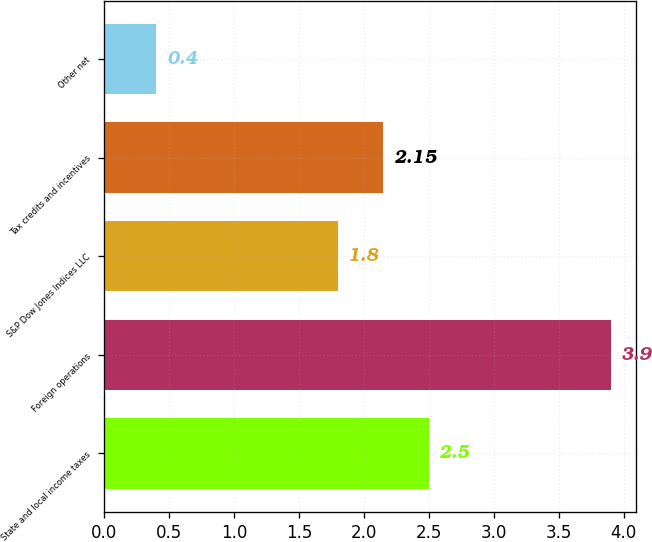Convert chart to OTSL. <chart><loc_0><loc_0><loc_500><loc_500><bar_chart><fcel>State and local income taxes<fcel>Foreign operations<fcel>S&P Dow Jones Indices LLC<fcel>Tax credits and incentives<fcel>Other net<nl><fcel>2.5<fcel>3.9<fcel>1.8<fcel>2.15<fcel>0.4<nl></chart> 